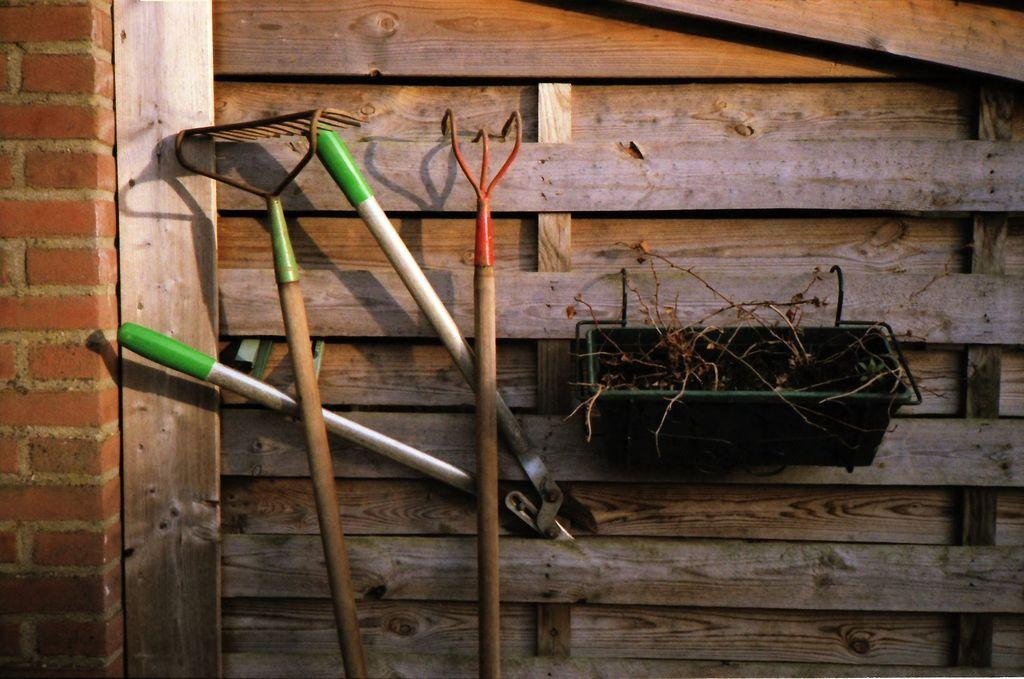What objects can be seen in the image that are used for specific tasks? There are tools in the image that are used for specific tasks. What type of container is present in the image? There is a basket in the image. What type of material is used to construct the wall in the image? There is a wooden wall in the image. What song is being sung by the tools in the image? There are no tools singing in the image; they are inanimate objects used for specific tasks. What discovery was made by the basket in the image? There is no discovery made by the basket in the image; it is a container used for holding items. 